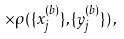Convert formula to latex. <formula><loc_0><loc_0><loc_500><loc_500>\times \rho ( \{ x _ { j } ^ { ( b ) } \} , \{ y _ { j } ^ { ( b ) } \} ) \, ,</formula> 